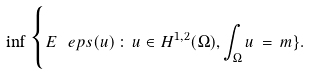<formula> <loc_0><loc_0><loc_500><loc_500>\inf \Big \{ E _ { \ } e p s ( u ) \, \colon \, u \in H ^ { 1 , 2 } ( \Omega ) , \int _ { \Omega } u \, = \, m \} .</formula> 